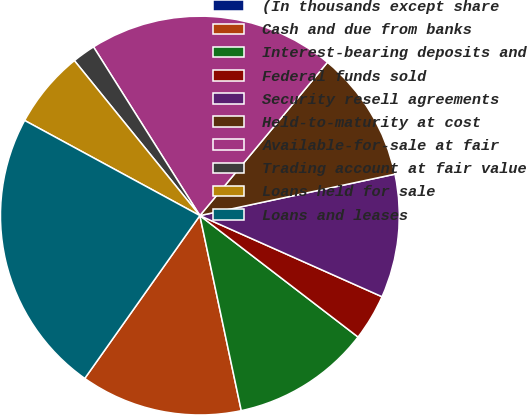Convert chart. <chart><loc_0><loc_0><loc_500><loc_500><pie_chart><fcel>(In thousands except share<fcel>Cash and due from banks<fcel>Interest-bearing deposits and<fcel>Federal funds sold<fcel>Security resell agreements<fcel>Held-to-maturity at cost<fcel>Available-for-sale at fair<fcel>Trading account at fair value<fcel>Loans held for sale<fcel>Loans and leases<nl><fcel>0.0%<fcel>13.12%<fcel>11.25%<fcel>3.75%<fcel>10.0%<fcel>10.62%<fcel>20.0%<fcel>1.88%<fcel>6.25%<fcel>23.12%<nl></chart> 